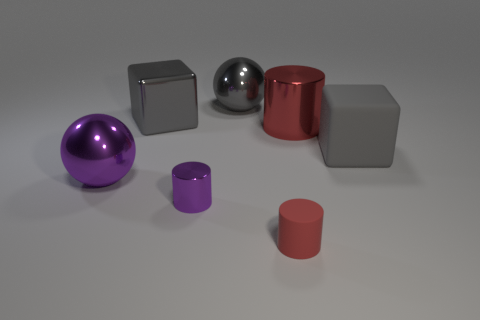Subtract all shiny cylinders. How many cylinders are left? 1 Add 1 green metal cylinders. How many objects exist? 8 Subtract all purple cylinders. How many cylinders are left? 2 Subtract 3 cylinders. How many cylinders are left? 0 Subtract all red cylinders. Subtract all green spheres. How many cylinders are left? 1 Subtract all red spheres. How many red cylinders are left? 2 Subtract all yellow cylinders. Subtract all large red things. How many objects are left? 6 Add 5 red matte cylinders. How many red matte cylinders are left? 6 Add 7 large red metal objects. How many large red metal objects exist? 8 Subtract 2 gray blocks. How many objects are left? 5 